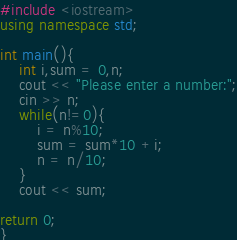<code> <loc_0><loc_0><loc_500><loc_500><_C++_>#include <iostream>
using namespace std;

int main(){
    int i,sum = 0,n;
    cout << "Please enter a number:";
    cin >> n;
    while(n!=0){
        i = n%10;
        sum = sum*10 +i;
        n = n/10;
    }
    cout << sum;

return 0;
}</code> 